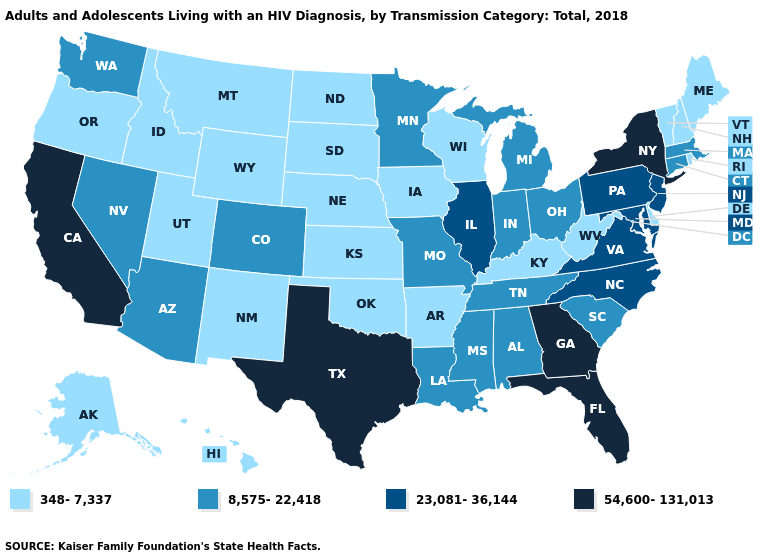What is the value of Mississippi?
Quick response, please. 8,575-22,418. Does Wisconsin have a lower value than Alabama?
Short answer required. Yes. What is the value of Maine?
Write a very short answer. 348-7,337. Is the legend a continuous bar?
Short answer required. No. Does Nebraska have a lower value than South Carolina?
Quick response, please. Yes. What is the highest value in states that border New Jersey?
Answer briefly. 54,600-131,013. Name the states that have a value in the range 8,575-22,418?
Be succinct. Alabama, Arizona, Colorado, Connecticut, Indiana, Louisiana, Massachusetts, Michigan, Minnesota, Mississippi, Missouri, Nevada, Ohio, South Carolina, Tennessee, Washington. How many symbols are there in the legend?
Keep it brief. 4. Name the states that have a value in the range 8,575-22,418?
Be succinct. Alabama, Arizona, Colorado, Connecticut, Indiana, Louisiana, Massachusetts, Michigan, Minnesota, Mississippi, Missouri, Nevada, Ohio, South Carolina, Tennessee, Washington. Does Arkansas have the lowest value in the South?
Quick response, please. Yes. Among the states that border New Mexico , which have the lowest value?
Write a very short answer. Oklahoma, Utah. Among the states that border Missouri , does Illinois have the lowest value?
Short answer required. No. Name the states that have a value in the range 54,600-131,013?
Concise answer only. California, Florida, Georgia, New York, Texas. Name the states that have a value in the range 23,081-36,144?
Be succinct. Illinois, Maryland, New Jersey, North Carolina, Pennsylvania, Virginia. 